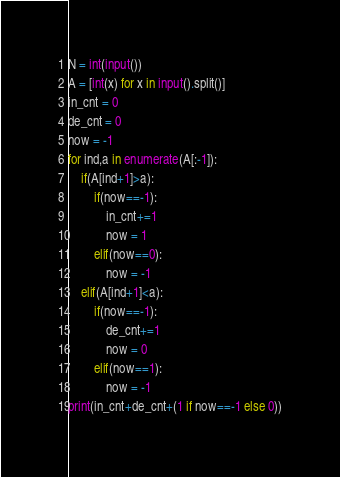Convert code to text. <code><loc_0><loc_0><loc_500><loc_500><_Python_>N = int(input())
A = [int(x) for x in input().split()]
in_cnt = 0
de_cnt = 0
now = -1
for ind,a in enumerate(A[:-1]):
    if(A[ind+1]>a):
        if(now==-1):
            in_cnt+=1
            now = 1
        elif(now==0):
            now = -1
    elif(A[ind+1]<a):
        if(now==-1):
            de_cnt+=1
            now = 0
        elif(now==1):
            now = -1
print(in_cnt+de_cnt+(1 if now==-1 else 0))
</code> 